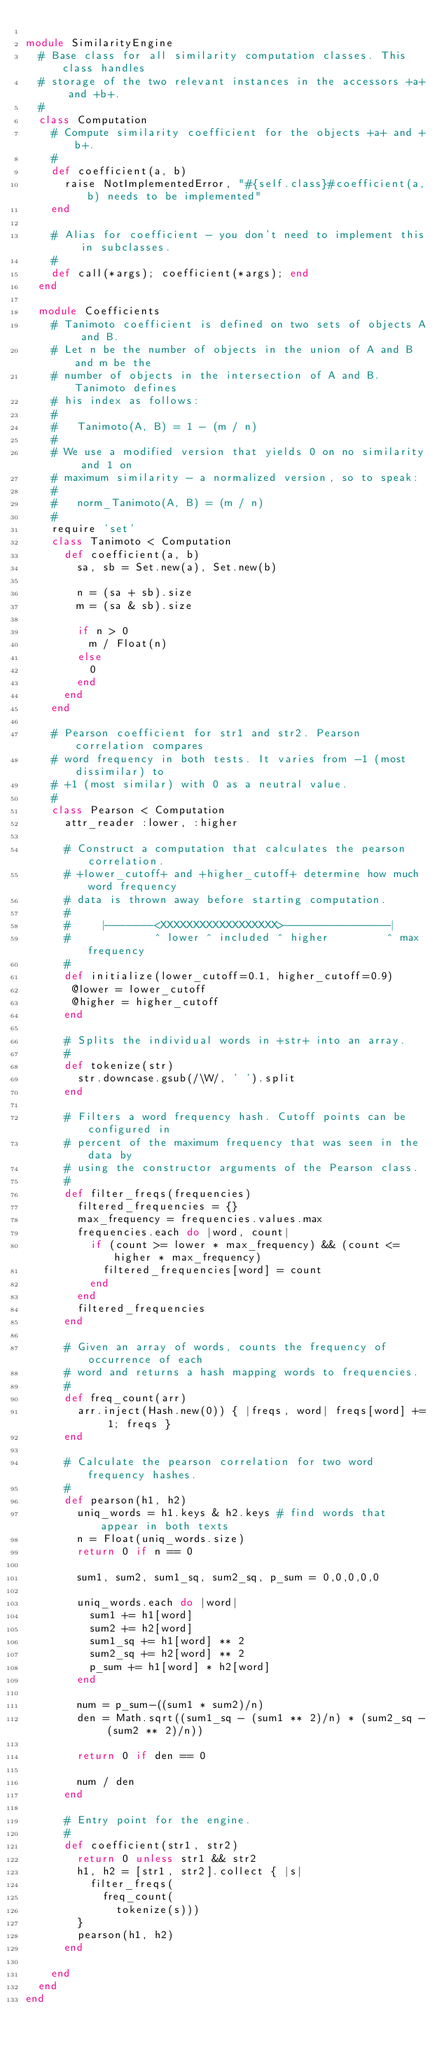<code> <loc_0><loc_0><loc_500><loc_500><_Ruby_>
module SimilarityEngine
  # Base class for all similarity computation classes. This class handles 
  # storage of the two relevant instances in the accessors +a+ and +b+. 
  #
  class Computation
    # Compute similarity coefficient for the objects +a+ and +b+. 
    #
    def coefficient(a, b)
      raise NotImplementedError, "#{self.class}#coefficient(a,b) needs to be implemented"
    end
    
    # Alias for coefficient - you don't need to implement this in subclasses.
    #
    def call(*args); coefficient(*args); end
  end
  
  module Coefficients
    # Tanimoto coefficient is defined on two sets of objects A and B. 
    # Let n be the number of objects in the union of A and B and m be the 
    # number of objects in the intersection of A and B. Tanimoto defines
    # his index as follows: 
    #
    #   Tanimoto(A, B) = 1 - (m / n)
    # 
    # We use a modified version that yields 0 on no similarity and 1 on 
    # maximum similarity - a normalized version, so to speak: 
    #
    #   norm_Tanimoto(A, B) = (m / n)
    #
    require 'set'
    class Tanimoto < Computation
      def coefficient(a, b)
        sa, sb = Set.new(a), Set.new(b)
      
        n = (sa + sb).size
        m = (sa & sb).size
      
        if n > 0
          m / Float(n)
        else 
          0
        end
      end
    end
    
    # Pearson coefficient for str1 and str2. Pearson correlation compares 
    # word frequency in both tests. It varies from -1 (most dissimilar) to 
    # +1 (most similar) with 0 as a neutral value. 
    #
    class Pearson < Computation
      attr_reader :lower, :higher
      
      # Construct a computation that calculates the pearson correlation. 
      # +lower_cutoff+ and +higher_cutoff+ determine how much word frequency
      # data is thrown away before starting computation. 
      #
      #     |-------<XXXXXXXXXXXXXXXXXX>----------------| 
      #             ^ lower ^ included ^ higher         ^ max frequency
      #
      def initialize(lower_cutoff=0.1, higher_cutoff=0.9)
       @lower = lower_cutoff
       @higher = higher_cutoff 
      end

      # Splits the individual words in +str+ into an array. 
      #
      def tokenize(str)
        str.downcase.gsub(/\W/, ' ').split
      end
      
      # Filters a word frequency hash. Cutoff points can be configured in 
      # percent of the maximum frequency that was seen in the data by 
      # using the constructor arguments of the Pearson class. 
      #
      def filter_freqs(frequencies)
        filtered_frequencies = {}
        max_frequency = frequencies.values.max
        frequencies.each do |word, count|
          if (count >= lower * max_frequency) && (count <= higher * max_frequency)
            filtered_frequencies[word] = count 
          end
        end
        filtered_frequencies
      end
      
      # Given an array of words, counts the frequency of occurrence of each 
      # word and returns a hash mapping words to frequencies. 
      #
      def freq_count(arr)
        arr.inject(Hash.new(0)) { |freqs, word| freqs[word] += 1; freqs }
      end
      
      # Calculate the pearson correlation for two word frequency hashes. 
      #
      def pearson(h1, h2)
        uniq_words = h1.keys & h2.keys # find words that appear in both texts
        n = Float(uniq_words.size)
        return 0 if n == 0

        sum1, sum2, sum1_sq, sum2_sq, p_sum = 0,0,0,0,0
      
        uniq_words.each do |word|
          sum1 += h1[word]
          sum2 += h2[word]
          sum1_sq += h1[word] ** 2
          sum2_sq += h2[word] ** 2
          p_sum += h1[word] * h2[word]
        end

        num = p_sum-((sum1 * sum2)/n) 
        den = Math.sqrt((sum1_sq - (sum1 ** 2)/n) * (sum2_sq - (sum2 ** 2)/n))

        return 0 if den == 0

        num / den
      end
      
      # Entry point for the engine. 
      #
      def coefficient(str1, str2)
        return 0 unless str1 && str2
        h1, h2 = [str1, str2].collect { |s| 
          filter_freqs(
            freq_count(
              tokenize(s)))  
        }
        pearson(h1, h2)
      end
      
    end
  end
end</code> 